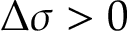<formula> <loc_0><loc_0><loc_500><loc_500>\Delta \sigma > 0</formula> 